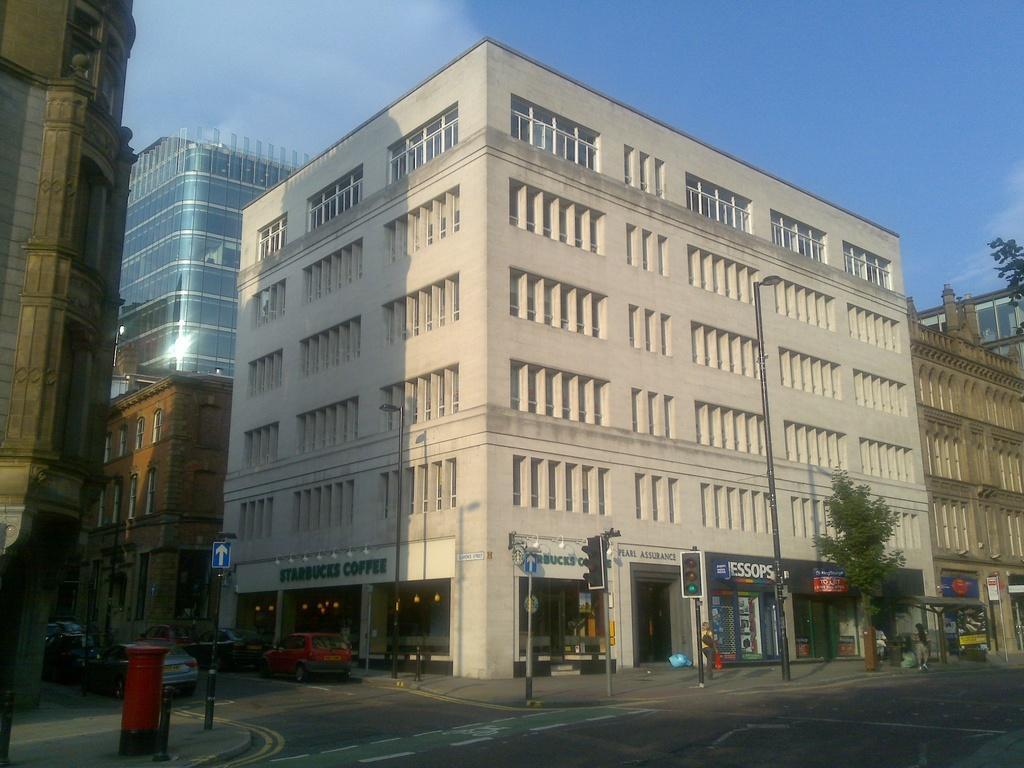Could you give a brief overview of what you see in this image? This picture might be taken from outside of the city and it is very sunny. In this image, on the right side, we can see street light, trees and foot path and a person is walking on the footpath. On the left side, we can also see buildings, post box, pole. In the background, we can see some cars, buildings. On top there is a sky, at the bottom there is a road. 